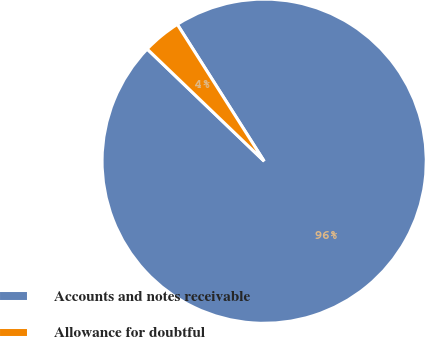Convert chart. <chart><loc_0><loc_0><loc_500><loc_500><pie_chart><fcel>Accounts and notes receivable<fcel>Allowance for doubtful<nl><fcel>96.17%<fcel>3.83%<nl></chart> 